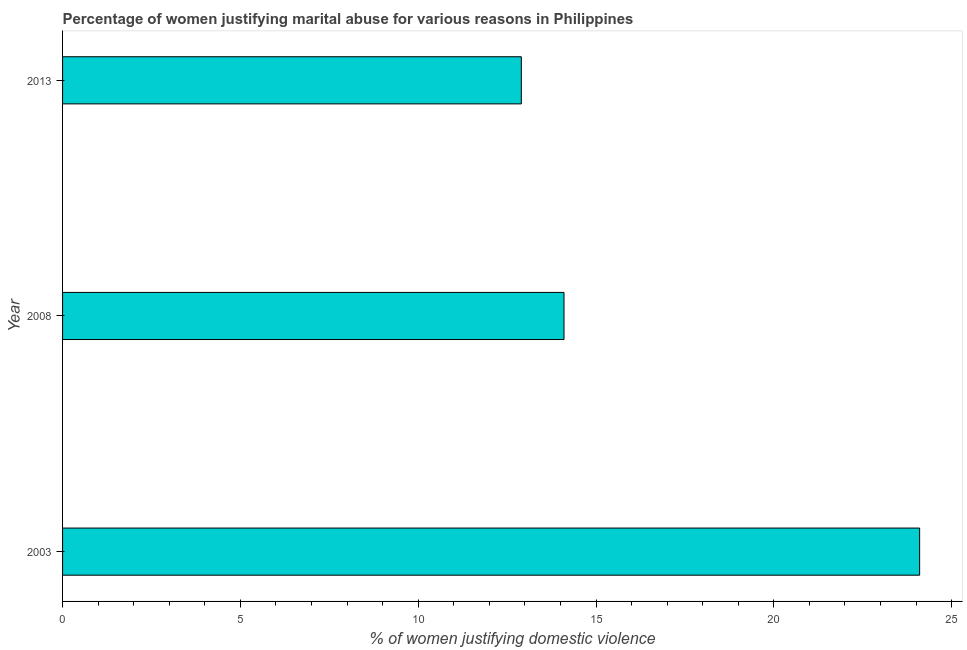Does the graph contain grids?
Give a very brief answer. No. What is the title of the graph?
Your answer should be compact. Percentage of women justifying marital abuse for various reasons in Philippines. What is the label or title of the X-axis?
Offer a terse response. % of women justifying domestic violence. What is the label or title of the Y-axis?
Ensure brevity in your answer.  Year. What is the percentage of women justifying marital abuse in 2003?
Provide a short and direct response. 24.1. Across all years, what is the maximum percentage of women justifying marital abuse?
Offer a very short reply. 24.1. Across all years, what is the minimum percentage of women justifying marital abuse?
Your answer should be compact. 12.9. In which year was the percentage of women justifying marital abuse maximum?
Your answer should be very brief. 2003. What is the sum of the percentage of women justifying marital abuse?
Your answer should be compact. 51.1. What is the average percentage of women justifying marital abuse per year?
Provide a short and direct response. 17.03. In how many years, is the percentage of women justifying marital abuse greater than 2 %?
Provide a succinct answer. 3. What is the ratio of the percentage of women justifying marital abuse in 2003 to that in 2008?
Make the answer very short. 1.71. Is the difference between the percentage of women justifying marital abuse in 2003 and 2008 greater than the difference between any two years?
Provide a short and direct response. No. What is the difference between the highest and the second highest percentage of women justifying marital abuse?
Your answer should be very brief. 10. Is the sum of the percentage of women justifying marital abuse in 2003 and 2013 greater than the maximum percentage of women justifying marital abuse across all years?
Give a very brief answer. Yes. What is the difference between the highest and the lowest percentage of women justifying marital abuse?
Ensure brevity in your answer.  11.2. How many years are there in the graph?
Provide a succinct answer. 3. Are the values on the major ticks of X-axis written in scientific E-notation?
Ensure brevity in your answer.  No. What is the % of women justifying domestic violence in 2003?
Offer a very short reply. 24.1. What is the % of women justifying domestic violence of 2013?
Your answer should be compact. 12.9. What is the difference between the % of women justifying domestic violence in 2003 and 2008?
Keep it short and to the point. 10. What is the difference between the % of women justifying domestic violence in 2003 and 2013?
Your response must be concise. 11.2. What is the difference between the % of women justifying domestic violence in 2008 and 2013?
Your response must be concise. 1.2. What is the ratio of the % of women justifying domestic violence in 2003 to that in 2008?
Offer a terse response. 1.71. What is the ratio of the % of women justifying domestic violence in 2003 to that in 2013?
Your answer should be compact. 1.87. What is the ratio of the % of women justifying domestic violence in 2008 to that in 2013?
Your answer should be very brief. 1.09. 